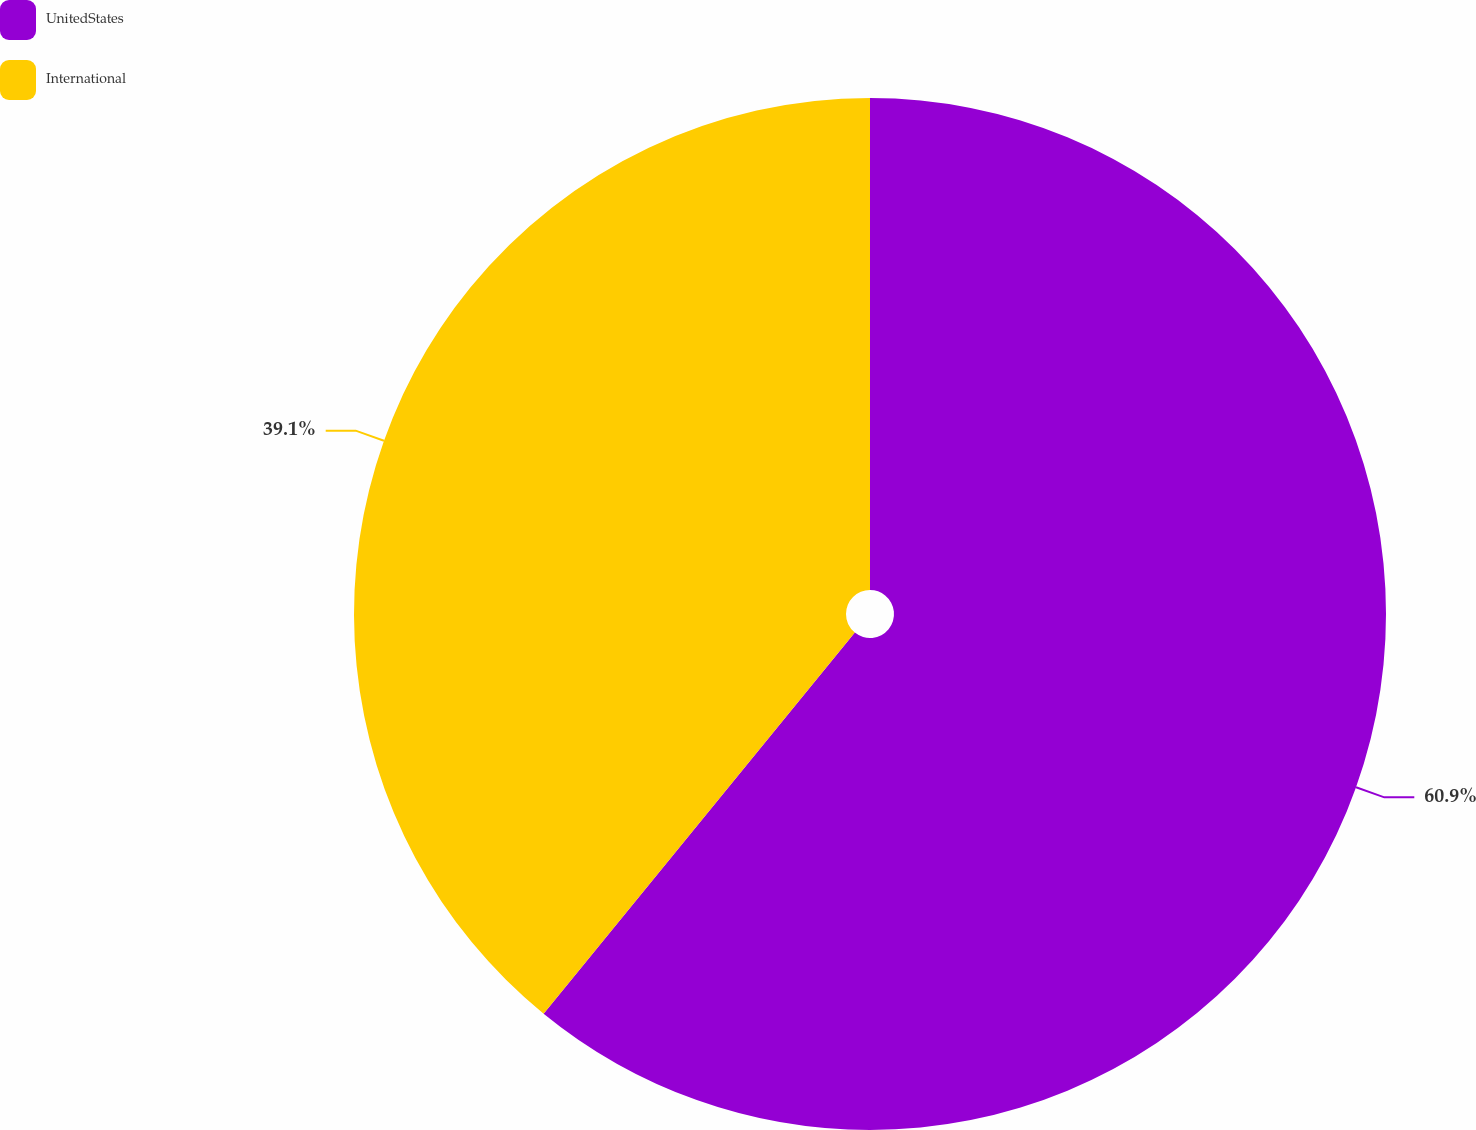<chart> <loc_0><loc_0><loc_500><loc_500><pie_chart><fcel>UnitedStates<fcel>International<nl><fcel>60.9%<fcel>39.1%<nl></chart> 